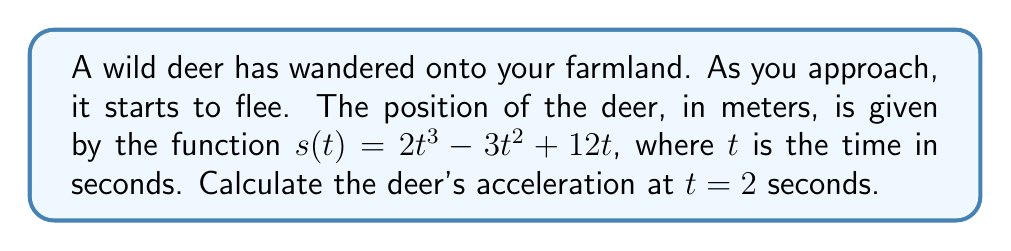Help me with this question. To find the acceleration of the deer at $t = 2$ seconds, we need to follow these steps:

1) First, we need to find the velocity function $v(t)$. The velocity is the first derivative of the position function:

   $v(t) = s'(t) = \frac{d}{dt}(2t^3 - 3t^2 + 12t)$
   $v(t) = 6t^2 - 6t + 12$

2) Now, we need to find the acceleration function $a(t)$. The acceleration is the second derivative of the position function, or the first derivative of the velocity function:

   $a(t) = v'(t) = \frac{d}{dt}(6t^2 - 6t + 12)$
   $a(t) = 12t - 6$

3) To find the acceleration at $t = 2$ seconds, we simply plug $t = 2$ into our acceleration function:

   $a(2) = 12(2) - 6$
   $a(2) = 24 - 6 = 18$

Therefore, the deer's acceleration at $t = 2$ seconds is 18 m/s².
Answer: 18 m/s² 